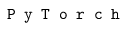<formula> <loc_0><loc_0><loc_500><loc_500>P y T o r c h</formula> 